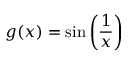<formula> <loc_0><loc_0><loc_500><loc_500>g ( x ) = \sin \left ( { \frac { 1 } { x } } \right )</formula> 